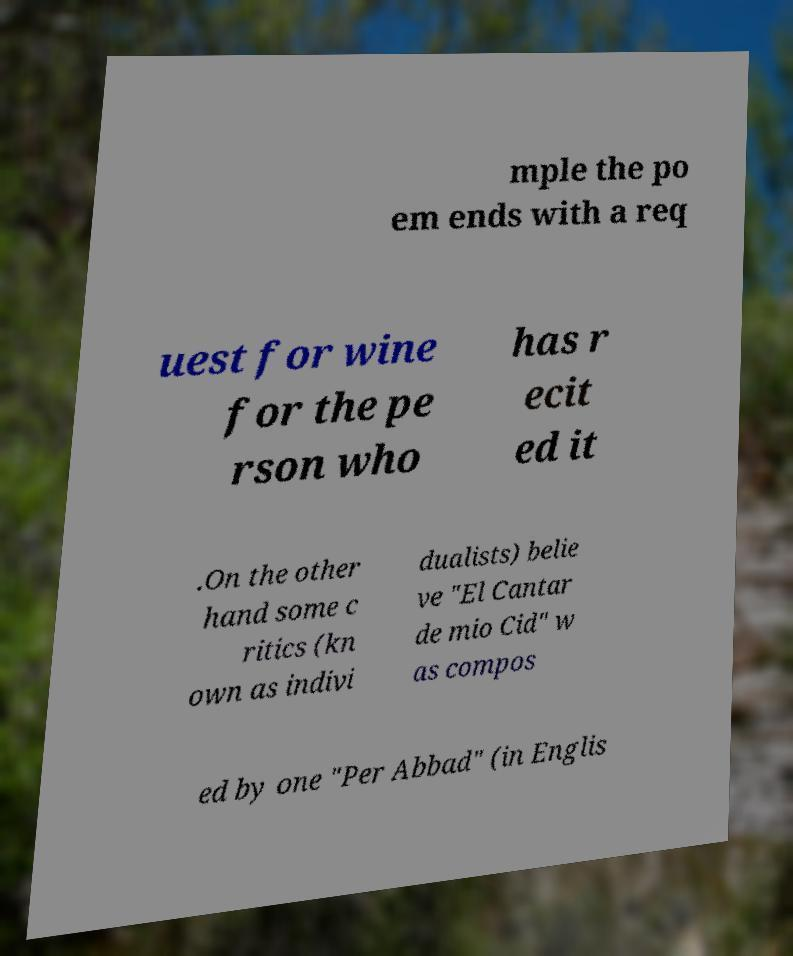Please read and relay the text visible in this image. What does it say? mple the po em ends with a req uest for wine for the pe rson who has r ecit ed it .On the other hand some c ritics (kn own as indivi dualists) belie ve "El Cantar de mio Cid" w as compos ed by one "Per Abbad" (in Englis 